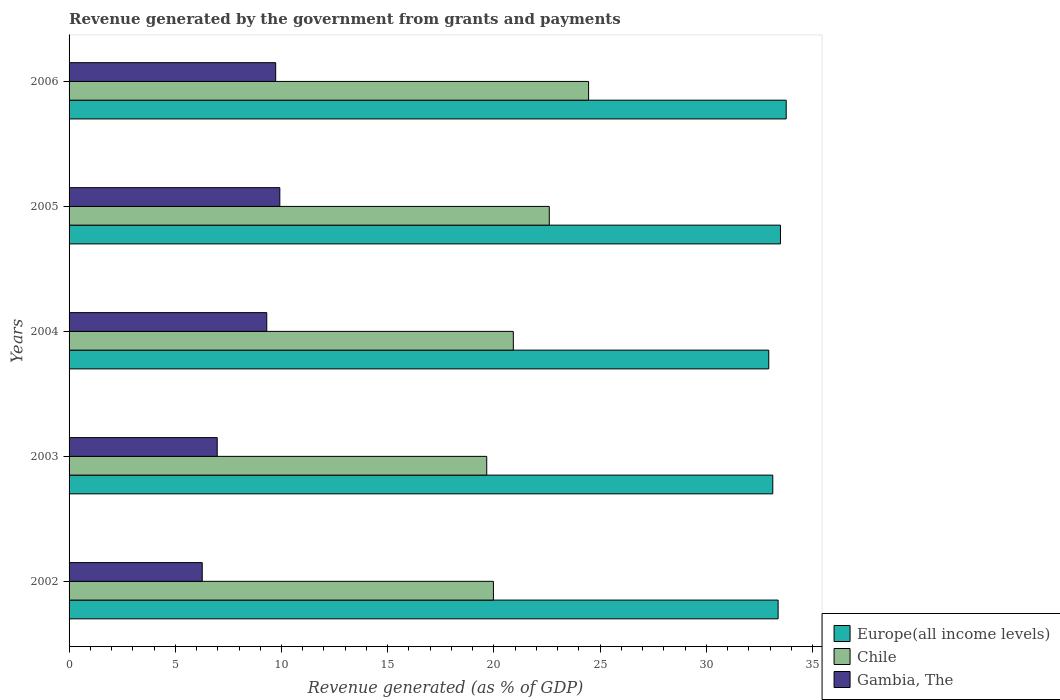How many different coloured bars are there?
Provide a short and direct response. 3. How many groups of bars are there?
Make the answer very short. 5. Are the number of bars per tick equal to the number of legend labels?
Your answer should be compact. Yes. How many bars are there on the 3rd tick from the top?
Ensure brevity in your answer.  3. How many bars are there on the 2nd tick from the bottom?
Ensure brevity in your answer.  3. In how many cases, is the number of bars for a given year not equal to the number of legend labels?
Provide a short and direct response. 0. What is the revenue generated by the government in Europe(all income levels) in 2006?
Offer a terse response. 33.76. Across all years, what is the maximum revenue generated by the government in Europe(all income levels)?
Provide a succinct answer. 33.76. Across all years, what is the minimum revenue generated by the government in Gambia, The?
Provide a short and direct response. 6.27. What is the total revenue generated by the government in Europe(all income levels) in the graph?
Your answer should be compact. 166.71. What is the difference between the revenue generated by the government in Gambia, The in 2003 and that in 2005?
Your answer should be compact. -2.95. What is the difference between the revenue generated by the government in Gambia, The in 2004 and the revenue generated by the government in Chile in 2006?
Ensure brevity in your answer.  -15.15. What is the average revenue generated by the government in Gambia, The per year?
Make the answer very short. 8.44. In the year 2005, what is the difference between the revenue generated by the government in Europe(all income levels) and revenue generated by the government in Chile?
Keep it short and to the point. 10.88. In how many years, is the revenue generated by the government in Europe(all income levels) greater than 25 %?
Make the answer very short. 5. What is the ratio of the revenue generated by the government in Chile in 2002 to that in 2005?
Your response must be concise. 0.88. Is the difference between the revenue generated by the government in Europe(all income levels) in 2003 and 2006 greater than the difference between the revenue generated by the government in Chile in 2003 and 2006?
Offer a terse response. Yes. What is the difference between the highest and the second highest revenue generated by the government in Gambia, The?
Keep it short and to the point. 0.2. What is the difference between the highest and the lowest revenue generated by the government in Europe(all income levels)?
Offer a very short reply. 0.82. What does the 3rd bar from the top in 2004 represents?
Your answer should be very brief. Europe(all income levels). Are all the bars in the graph horizontal?
Give a very brief answer. Yes. How many years are there in the graph?
Ensure brevity in your answer.  5. What is the difference between two consecutive major ticks on the X-axis?
Offer a very short reply. 5. Are the values on the major ticks of X-axis written in scientific E-notation?
Your answer should be very brief. No. Does the graph contain grids?
Provide a short and direct response. No. Where does the legend appear in the graph?
Make the answer very short. Bottom right. How many legend labels are there?
Your answer should be compact. 3. What is the title of the graph?
Keep it short and to the point. Revenue generated by the government from grants and payments. Does "Euro area" appear as one of the legend labels in the graph?
Keep it short and to the point. No. What is the label or title of the X-axis?
Your response must be concise. Revenue generated (as % of GDP). What is the Revenue generated (as % of GDP) of Europe(all income levels) in 2002?
Your answer should be compact. 33.38. What is the Revenue generated (as % of GDP) of Chile in 2002?
Offer a terse response. 19.98. What is the Revenue generated (as % of GDP) in Gambia, The in 2002?
Your answer should be very brief. 6.27. What is the Revenue generated (as % of GDP) in Europe(all income levels) in 2003?
Ensure brevity in your answer.  33.13. What is the Revenue generated (as % of GDP) of Chile in 2003?
Provide a succinct answer. 19.66. What is the Revenue generated (as % of GDP) in Gambia, The in 2003?
Make the answer very short. 6.97. What is the Revenue generated (as % of GDP) of Europe(all income levels) in 2004?
Your answer should be compact. 32.94. What is the Revenue generated (as % of GDP) in Chile in 2004?
Keep it short and to the point. 20.92. What is the Revenue generated (as % of GDP) of Gambia, The in 2004?
Keep it short and to the point. 9.31. What is the Revenue generated (as % of GDP) of Europe(all income levels) in 2005?
Offer a very short reply. 33.49. What is the Revenue generated (as % of GDP) of Chile in 2005?
Your answer should be compact. 22.61. What is the Revenue generated (as % of GDP) of Gambia, The in 2005?
Your answer should be very brief. 9.92. What is the Revenue generated (as % of GDP) in Europe(all income levels) in 2006?
Keep it short and to the point. 33.76. What is the Revenue generated (as % of GDP) of Chile in 2006?
Keep it short and to the point. 24.46. What is the Revenue generated (as % of GDP) of Gambia, The in 2006?
Offer a very short reply. 9.73. Across all years, what is the maximum Revenue generated (as % of GDP) in Europe(all income levels)?
Offer a terse response. 33.76. Across all years, what is the maximum Revenue generated (as % of GDP) in Chile?
Give a very brief answer. 24.46. Across all years, what is the maximum Revenue generated (as % of GDP) in Gambia, The?
Give a very brief answer. 9.92. Across all years, what is the minimum Revenue generated (as % of GDP) of Europe(all income levels)?
Provide a short and direct response. 32.94. Across all years, what is the minimum Revenue generated (as % of GDP) in Chile?
Your response must be concise. 19.66. Across all years, what is the minimum Revenue generated (as % of GDP) in Gambia, The?
Make the answer very short. 6.27. What is the total Revenue generated (as % of GDP) of Europe(all income levels) in the graph?
Offer a very short reply. 166.71. What is the total Revenue generated (as % of GDP) of Chile in the graph?
Make the answer very short. 107.63. What is the total Revenue generated (as % of GDP) of Gambia, The in the graph?
Make the answer very short. 42.2. What is the difference between the Revenue generated (as % of GDP) of Europe(all income levels) in 2002 and that in 2003?
Give a very brief answer. 0.25. What is the difference between the Revenue generated (as % of GDP) in Chile in 2002 and that in 2003?
Give a very brief answer. 0.32. What is the difference between the Revenue generated (as % of GDP) of Gambia, The in 2002 and that in 2003?
Offer a terse response. -0.71. What is the difference between the Revenue generated (as % of GDP) in Europe(all income levels) in 2002 and that in 2004?
Your response must be concise. 0.44. What is the difference between the Revenue generated (as % of GDP) of Chile in 2002 and that in 2004?
Your answer should be compact. -0.94. What is the difference between the Revenue generated (as % of GDP) in Gambia, The in 2002 and that in 2004?
Make the answer very short. -3.04. What is the difference between the Revenue generated (as % of GDP) of Europe(all income levels) in 2002 and that in 2005?
Make the answer very short. -0.11. What is the difference between the Revenue generated (as % of GDP) in Chile in 2002 and that in 2005?
Provide a short and direct response. -2.63. What is the difference between the Revenue generated (as % of GDP) of Gambia, The in 2002 and that in 2005?
Your answer should be compact. -3.65. What is the difference between the Revenue generated (as % of GDP) in Europe(all income levels) in 2002 and that in 2006?
Provide a short and direct response. -0.38. What is the difference between the Revenue generated (as % of GDP) of Chile in 2002 and that in 2006?
Give a very brief answer. -4.48. What is the difference between the Revenue generated (as % of GDP) in Gambia, The in 2002 and that in 2006?
Ensure brevity in your answer.  -3.46. What is the difference between the Revenue generated (as % of GDP) of Europe(all income levels) in 2003 and that in 2004?
Your answer should be very brief. 0.19. What is the difference between the Revenue generated (as % of GDP) of Chile in 2003 and that in 2004?
Give a very brief answer. -1.25. What is the difference between the Revenue generated (as % of GDP) in Gambia, The in 2003 and that in 2004?
Provide a succinct answer. -2.33. What is the difference between the Revenue generated (as % of GDP) of Europe(all income levels) in 2003 and that in 2005?
Offer a terse response. -0.36. What is the difference between the Revenue generated (as % of GDP) in Chile in 2003 and that in 2005?
Offer a terse response. -2.94. What is the difference between the Revenue generated (as % of GDP) in Gambia, The in 2003 and that in 2005?
Provide a succinct answer. -2.95. What is the difference between the Revenue generated (as % of GDP) in Europe(all income levels) in 2003 and that in 2006?
Keep it short and to the point. -0.63. What is the difference between the Revenue generated (as % of GDP) in Chile in 2003 and that in 2006?
Offer a very short reply. -4.8. What is the difference between the Revenue generated (as % of GDP) of Gambia, The in 2003 and that in 2006?
Keep it short and to the point. -2.75. What is the difference between the Revenue generated (as % of GDP) of Europe(all income levels) in 2004 and that in 2005?
Your answer should be very brief. -0.55. What is the difference between the Revenue generated (as % of GDP) in Chile in 2004 and that in 2005?
Make the answer very short. -1.69. What is the difference between the Revenue generated (as % of GDP) in Gambia, The in 2004 and that in 2005?
Provide a succinct answer. -0.62. What is the difference between the Revenue generated (as % of GDP) of Europe(all income levels) in 2004 and that in 2006?
Your response must be concise. -0.82. What is the difference between the Revenue generated (as % of GDP) of Chile in 2004 and that in 2006?
Your answer should be very brief. -3.54. What is the difference between the Revenue generated (as % of GDP) of Gambia, The in 2004 and that in 2006?
Offer a very short reply. -0.42. What is the difference between the Revenue generated (as % of GDP) in Europe(all income levels) in 2005 and that in 2006?
Offer a terse response. -0.27. What is the difference between the Revenue generated (as % of GDP) of Chile in 2005 and that in 2006?
Offer a very short reply. -1.85. What is the difference between the Revenue generated (as % of GDP) of Gambia, The in 2005 and that in 2006?
Your answer should be very brief. 0.2. What is the difference between the Revenue generated (as % of GDP) in Europe(all income levels) in 2002 and the Revenue generated (as % of GDP) in Chile in 2003?
Make the answer very short. 13.72. What is the difference between the Revenue generated (as % of GDP) of Europe(all income levels) in 2002 and the Revenue generated (as % of GDP) of Gambia, The in 2003?
Your answer should be very brief. 26.41. What is the difference between the Revenue generated (as % of GDP) in Chile in 2002 and the Revenue generated (as % of GDP) in Gambia, The in 2003?
Give a very brief answer. 13. What is the difference between the Revenue generated (as % of GDP) of Europe(all income levels) in 2002 and the Revenue generated (as % of GDP) of Chile in 2004?
Offer a terse response. 12.47. What is the difference between the Revenue generated (as % of GDP) in Europe(all income levels) in 2002 and the Revenue generated (as % of GDP) in Gambia, The in 2004?
Ensure brevity in your answer.  24.08. What is the difference between the Revenue generated (as % of GDP) of Chile in 2002 and the Revenue generated (as % of GDP) of Gambia, The in 2004?
Keep it short and to the point. 10.67. What is the difference between the Revenue generated (as % of GDP) in Europe(all income levels) in 2002 and the Revenue generated (as % of GDP) in Chile in 2005?
Your answer should be compact. 10.77. What is the difference between the Revenue generated (as % of GDP) in Europe(all income levels) in 2002 and the Revenue generated (as % of GDP) in Gambia, The in 2005?
Give a very brief answer. 23.46. What is the difference between the Revenue generated (as % of GDP) in Chile in 2002 and the Revenue generated (as % of GDP) in Gambia, The in 2005?
Offer a terse response. 10.06. What is the difference between the Revenue generated (as % of GDP) of Europe(all income levels) in 2002 and the Revenue generated (as % of GDP) of Chile in 2006?
Provide a short and direct response. 8.92. What is the difference between the Revenue generated (as % of GDP) in Europe(all income levels) in 2002 and the Revenue generated (as % of GDP) in Gambia, The in 2006?
Your answer should be compact. 23.66. What is the difference between the Revenue generated (as % of GDP) of Chile in 2002 and the Revenue generated (as % of GDP) of Gambia, The in 2006?
Offer a very short reply. 10.25. What is the difference between the Revenue generated (as % of GDP) in Europe(all income levels) in 2003 and the Revenue generated (as % of GDP) in Chile in 2004?
Your answer should be compact. 12.22. What is the difference between the Revenue generated (as % of GDP) in Europe(all income levels) in 2003 and the Revenue generated (as % of GDP) in Gambia, The in 2004?
Offer a terse response. 23.82. What is the difference between the Revenue generated (as % of GDP) of Chile in 2003 and the Revenue generated (as % of GDP) of Gambia, The in 2004?
Keep it short and to the point. 10.36. What is the difference between the Revenue generated (as % of GDP) in Europe(all income levels) in 2003 and the Revenue generated (as % of GDP) in Chile in 2005?
Provide a short and direct response. 10.52. What is the difference between the Revenue generated (as % of GDP) of Europe(all income levels) in 2003 and the Revenue generated (as % of GDP) of Gambia, The in 2005?
Provide a succinct answer. 23.21. What is the difference between the Revenue generated (as % of GDP) in Chile in 2003 and the Revenue generated (as % of GDP) in Gambia, The in 2005?
Ensure brevity in your answer.  9.74. What is the difference between the Revenue generated (as % of GDP) of Europe(all income levels) in 2003 and the Revenue generated (as % of GDP) of Chile in 2006?
Make the answer very short. 8.67. What is the difference between the Revenue generated (as % of GDP) in Europe(all income levels) in 2003 and the Revenue generated (as % of GDP) in Gambia, The in 2006?
Ensure brevity in your answer.  23.4. What is the difference between the Revenue generated (as % of GDP) in Chile in 2003 and the Revenue generated (as % of GDP) in Gambia, The in 2006?
Offer a very short reply. 9.94. What is the difference between the Revenue generated (as % of GDP) of Europe(all income levels) in 2004 and the Revenue generated (as % of GDP) of Chile in 2005?
Your response must be concise. 10.33. What is the difference between the Revenue generated (as % of GDP) in Europe(all income levels) in 2004 and the Revenue generated (as % of GDP) in Gambia, The in 2005?
Keep it short and to the point. 23.02. What is the difference between the Revenue generated (as % of GDP) in Chile in 2004 and the Revenue generated (as % of GDP) in Gambia, The in 2005?
Offer a very short reply. 10.99. What is the difference between the Revenue generated (as % of GDP) in Europe(all income levels) in 2004 and the Revenue generated (as % of GDP) in Chile in 2006?
Ensure brevity in your answer.  8.48. What is the difference between the Revenue generated (as % of GDP) in Europe(all income levels) in 2004 and the Revenue generated (as % of GDP) in Gambia, The in 2006?
Your answer should be very brief. 23.21. What is the difference between the Revenue generated (as % of GDP) in Chile in 2004 and the Revenue generated (as % of GDP) in Gambia, The in 2006?
Give a very brief answer. 11.19. What is the difference between the Revenue generated (as % of GDP) in Europe(all income levels) in 2005 and the Revenue generated (as % of GDP) in Chile in 2006?
Ensure brevity in your answer.  9.03. What is the difference between the Revenue generated (as % of GDP) in Europe(all income levels) in 2005 and the Revenue generated (as % of GDP) in Gambia, The in 2006?
Offer a terse response. 23.77. What is the difference between the Revenue generated (as % of GDP) of Chile in 2005 and the Revenue generated (as % of GDP) of Gambia, The in 2006?
Your answer should be compact. 12.88. What is the average Revenue generated (as % of GDP) of Europe(all income levels) per year?
Make the answer very short. 33.34. What is the average Revenue generated (as % of GDP) in Chile per year?
Provide a succinct answer. 21.53. What is the average Revenue generated (as % of GDP) of Gambia, The per year?
Offer a very short reply. 8.44. In the year 2002, what is the difference between the Revenue generated (as % of GDP) of Europe(all income levels) and Revenue generated (as % of GDP) of Chile?
Your response must be concise. 13.4. In the year 2002, what is the difference between the Revenue generated (as % of GDP) in Europe(all income levels) and Revenue generated (as % of GDP) in Gambia, The?
Keep it short and to the point. 27.11. In the year 2002, what is the difference between the Revenue generated (as % of GDP) of Chile and Revenue generated (as % of GDP) of Gambia, The?
Offer a very short reply. 13.71. In the year 2003, what is the difference between the Revenue generated (as % of GDP) of Europe(all income levels) and Revenue generated (as % of GDP) of Chile?
Offer a terse response. 13.47. In the year 2003, what is the difference between the Revenue generated (as % of GDP) in Europe(all income levels) and Revenue generated (as % of GDP) in Gambia, The?
Provide a succinct answer. 26.16. In the year 2003, what is the difference between the Revenue generated (as % of GDP) in Chile and Revenue generated (as % of GDP) in Gambia, The?
Offer a terse response. 12.69. In the year 2004, what is the difference between the Revenue generated (as % of GDP) of Europe(all income levels) and Revenue generated (as % of GDP) of Chile?
Your response must be concise. 12.03. In the year 2004, what is the difference between the Revenue generated (as % of GDP) in Europe(all income levels) and Revenue generated (as % of GDP) in Gambia, The?
Give a very brief answer. 23.63. In the year 2004, what is the difference between the Revenue generated (as % of GDP) in Chile and Revenue generated (as % of GDP) in Gambia, The?
Make the answer very short. 11.61. In the year 2005, what is the difference between the Revenue generated (as % of GDP) in Europe(all income levels) and Revenue generated (as % of GDP) in Chile?
Your answer should be very brief. 10.88. In the year 2005, what is the difference between the Revenue generated (as % of GDP) in Europe(all income levels) and Revenue generated (as % of GDP) in Gambia, The?
Your answer should be very brief. 23.57. In the year 2005, what is the difference between the Revenue generated (as % of GDP) in Chile and Revenue generated (as % of GDP) in Gambia, The?
Your answer should be compact. 12.69. In the year 2006, what is the difference between the Revenue generated (as % of GDP) of Europe(all income levels) and Revenue generated (as % of GDP) of Chile?
Your answer should be very brief. 9.3. In the year 2006, what is the difference between the Revenue generated (as % of GDP) of Europe(all income levels) and Revenue generated (as % of GDP) of Gambia, The?
Keep it short and to the point. 24.04. In the year 2006, what is the difference between the Revenue generated (as % of GDP) in Chile and Revenue generated (as % of GDP) in Gambia, The?
Your response must be concise. 14.73. What is the ratio of the Revenue generated (as % of GDP) of Europe(all income levels) in 2002 to that in 2003?
Offer a terse response. 1.01. What is the ratio of the Revenue generated (as % of GDP) of Chile in 2002 to that in 2003?
Offer a very short reply. 1.02. What is the ratio of the Revenue generated (as % of GDP) of Gambia, The in 2002 to that in 2003?
Offer a terse response. 0.9. What is the ratio of the Revenue generated (as % of GDP) of Europe(all income levels) in 2002 to that in 2004?
Your response must be concise. 1.01. What is the ratio of the Revenue generated (as % of GDP) of Chile in 2002 to that in 2004?
Provide a short and direct response. 0.96. What is the ratio of the Revenue generated (as % of GDP) of Gambia, The in 2002 to that in 2004?
Your answer should be very brief. 0.67. What is the ratio of the Revenue generated (as % of GDP) in Europe(all income levels) in 2002 to that in 2005?
Offer a very short reply. 1. What is the ratio of the Revenue generated (as % of GDP) in Chile in 2002 to that in 2005?
Provide a short and direct response. 0.88. What is the ratio of the Revenue generated (as % of GDP) of Gambia, The in 2002 to that in 2005?
Your answer should be very brief. 0.63. What is the ratio of the Revenue generated (as % of GDP) in Chile in 2002 to that in 2006?
Ensure brevity in your answer.  0.82. What is the ratio of the Revenue generated (as % of GDP) of Gambia, The in 2002 to that in 2006?
Ensure brevity in your answer.  0.64. What is the ratio of the Revenue generated (as % of GDP) of Europe(all income levels) in 2003 to that in 2004?
Ensure brevity in your answer.  1.01. What is the ratio of the Revenue generated (as % of GDP) of Chile in 2003 to that in 2004?
Your answer should be compact. 0.94. What is the ratio of the Revenue generated (as % of GDP) of Gambia, The in 2003 to that in 2004?
Offer a very short reply. 0.75. What is the ratio of the Revenue generated (as % of GDP) in Chile in 2003 to that in 2005?
Provide a short and direct response. 0.87. What is the ratio of the Revenue generated (as % of GDP) of Gambia, The in 2003 to that in 2005?
Make the answer very short. 0.7. What is the ratio of the Revenue generated (as % of GDP) in Europe(all income levels) in 2003 to that in 2006?
Your response must be concise. 0.98. What is the ratio of the Revenue generated (as % of GDP) in Chile in 2003 to that in 2006?
Offer a very short reply. 0.8. What is the ratio of the Revenue generated (as % of GDP) in Gambia, The in 2003 to that in 2006?
Make the answer very short. 0.72. What is the ratio of the Revenue generated (as % of GDP) in Europe(all income levels) in 2004 to that in 2005?
Give a very brief answer. 0.98. What is the ratio of the Revenue generated (as % of GDP) of Chile in 2004 to that in 2005?
Ensure brevity in your answer.  0.93. What is the ratio of the Revenue generated (as % of GDP) of Gambia, The in 2004 to that in 2005?
Provide a short and direct response. 0.94. What is the ratio of the Revenue generated (as % of GDP) of Europe(all income levels) in 2004 to that in 2006?
Provide a succinct answer. 0.98. What is the ratio of the Revenue generated (as % of GDP) of Chile in 2004 to that in 2006?
Offer a terse response. 0.86. What is the ratio of the Revenue generated (as % of GDP) of Gambia, The in 2004 to that in 2006?
Offer a terse response. 0.96. What is the ratio of the Revenue generated (as % of GDP) of Europe(all income levels) in 2005 to that in 2006?
Make the answer very short. 0.99. What is the ratio of the Revenue generated (as % of GDP) of Chile in 2005 to that in 2006?
Make the answer very short. 0.92. What is the ratio of the Revenue generated (as % of GDP) in Gambia, The in 2005 to that in 2006?
Offer a terse response. 1.02. What is the difference between the highest and the second highest Revenue generated (as % of GDP) in Europe(all income levels)?
Your answer should be compact. 0.27. What is the difference between the highest and the second highest Revenue generated (as % of GDP) of Chile?
Offer a terse response. 1.85. What is the difference between the highest and the second highest Revenue generated (as % of GDP) in Gambia, The?
Provide a succinct answer. 0.2. What is the difference between the highest and the lowest Revenue generated (as % of GDP) in Europe(all income levels)?
Ensure brevity in your answer.  0.82. What is the difference between the highest and the lowest Revenue generated (as % of GDP) of Chile?
Offer a terse response. 4.8. What is the difference between the highest and the lowest Revenue generated (as % of GDP) in Gambia, The?
Ensure brevity in your answer.  3.65. 